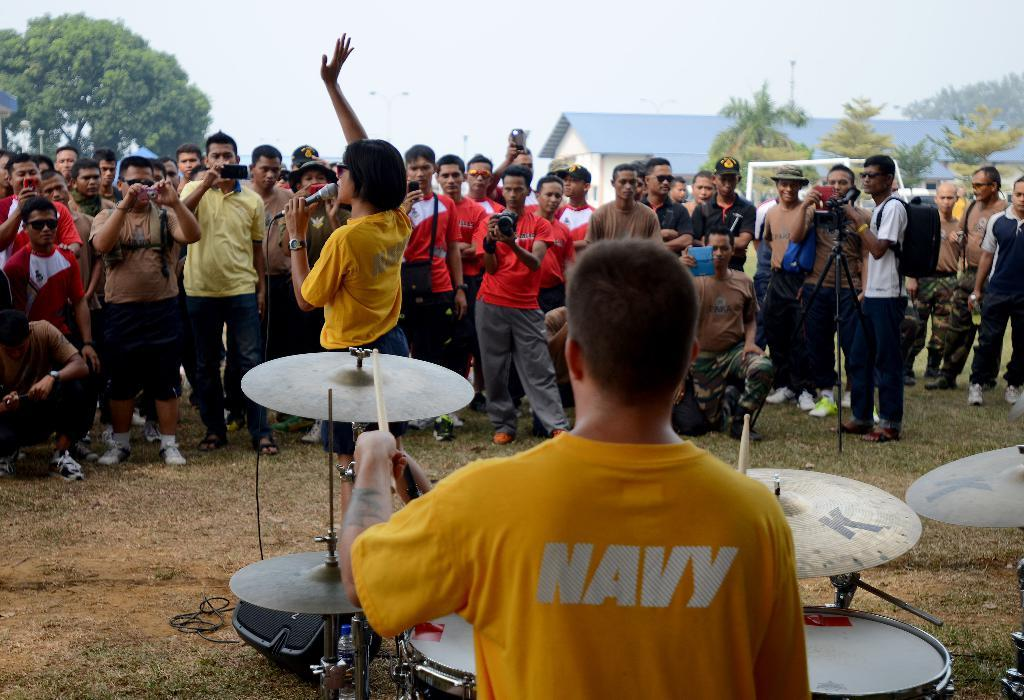What type of natural elements can be seen in the image? There are trees in the image. What part of the natural environment is visible in the image? The sky is visible in the image. What type of structure is present in the image? There is a shed in the image. What are the people in the image doing? There are people standing on the ground in the image. What equipment is present in the image related to photography or videography? A tripod and cameras are visible in the image. What equipment is present in the image related to music? Musical instruments and a mic are visible in the image. What type of cables are present in the image? Cables are present in the image. What type of paper is being used to create a special effect in the image? There is no paper or special effect present in the image. What type of cast is visible in the image? There is no cast present in the image. 